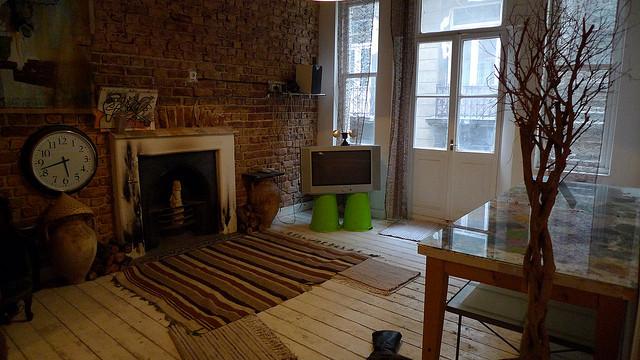What pattern is the floor?
Concise answer only. Stripes. What kind of clock is on the wall?
Give a very brief answer. Analog. How many trees do you see?
Concise answer only. 1. Is this a modern home?
Concise answer only. No. Is there a ladder?
Short answer required. No. What type of clock is shown?
Quick response, please. Analog. Was this picture taken with flash photography?
Keep it brief. No. Is this room cluttered?
Write a very short answer. No. What is on the table?
Be succinct. Nothing. What object is next to the chair, against the fireplace?
Be succinct. Clock. Where is the mirror?
Answer briefly. Nowhere. Is this a cabin?
Concise answer only. Yes. Is the vase on the table transparent or opaque?
Keep it brief. Opaque. Are there flowers in this picture?
Write a very short answer. No. What kind of heater is this room using?
Be succinct. Fireplace. What is the object on the right?
Short answer required. Table. Is there a fire in the fireplace?
Keep it brief. No. What shape is the table in the foreground?
Concise answer only. Rectangle. What is the main color in the area rug?
Quick response, please. Brown. Is this room on the top floor of the building?
Write a very short answer. Yes. Is the TV turned on?
Quick response, please. No. Why are the windows showing different colors?
Concise answer only. Because of blinds. Is the television on?
Concise answer only. No. Is there a vase on the table?
Write a very short answer. No. Is the table made of wood?
Be succinct. Yes. What color is the photo?
Keep it brief. Brown. What part of the house is this room located in?
Short answer required. Living room. How many rooms are shown?
Write a very short answer. 1. Is the window open?
Write a very short answer. No. Where is the throw rug?
Keep it brief. Floor. How many clocks do you see?
Concise answer only. 1. Is there a hand sculpture on the table?
Quick response, please. No. Is the door close?
Give a very brief answer. Yes. Is the kitchen and living room in one?
Write a very short answer. No. How is the room?
Quick response, please. Tidy. Is the light on?
Give a very brief answer. No. How many tables are empty?
Write a very short answer. 1. How many red squares can you see on the rug?
Keep it brief. 0. What time of day is it?
Be succinct. Afternoon. Did someone get married?
Concise answer only. No. Would you want a child living in this household?
Keep it brief. Yes. Is the clock digital or analog?
Keep it brief. Analog. Is this an outdoor patio?
Keep it brief. No. Where are the bikes?
Short answer required. Outside. What time of day is this?
Give a very brief answer. Morning. What type of skin is on the wall?
Give a very brief answer. None. Is there an animal?
Give a very brief answer. No. What color is the window frame?
Be succinct. White. What room is this?
Concise answer only. Living room. Is there a TV hanging on the wall?
Concise answer only. No. The black areas on the brick are evidence of what?
Give a very brief answer. Soot. How many crates are in  the photo?
Give a very brief answer. 0. What color is the wall?
Keep it brief. Brown. What type of rugs are these?
Keep it brief. Throw. What time does the clock read?
Concise answer only. 5:43. What is everything on the floor?
Answer briefly. Rugs. Does this look like a library?
Concise answer only. No. How many panes are visible on the windows?
Short answer required. 8. What time is it in the game?
Be succinct. 5:42. Is there a bike by the table?
Be succinct. No. How many houseplants are there?
Write a very short answer. 1. Does this look like a private residence or an event hosting site?
Concise answer only. Private residence. How many numbers are there?
Be succinct. 12. Are there any alcoholic beverages in this picture?
Quick response, please. No. Is there a shade on the window?
Quick response, please. No. What material is the building made of?
Be succinct. Brick. Is this a city?
Short answer required. Yes. Are the clock old?
Answer briefly. No. What time is it?
Answer briefly. 5:43. Is the TV on a normal TV stand?
Short answer required. No. Is this up to code?
Answer briefly. Yes. What type of numbers are on the clock?
Quick response, please. Time. Is the door open?
Answer briefly. No. Where is the rug located?
Short answer required. In front of fireplace. What color are the plants?
Keep it brief. Brown. What type of scene is this?
Give a very brief answer. Living room. Is there a "fur" blanket?
Give a very brief answer. No. Is the building new?
Concise answer only. No. What is this room?
Concise answer only. Living room. Are any of the windows stained glass?
Be succinct. No. 